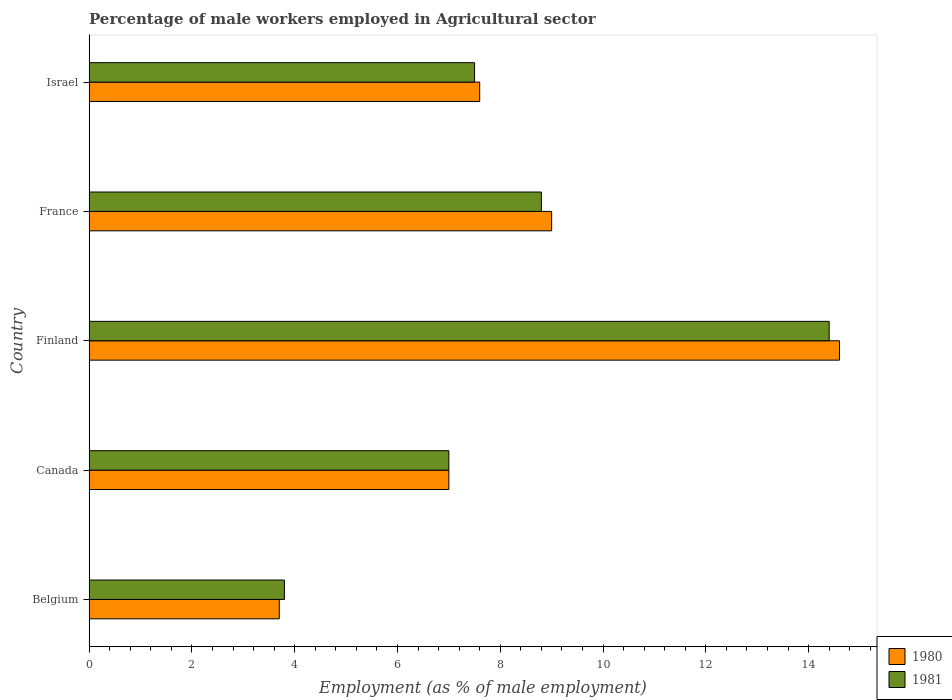How many groups of bars are there?
Provide a short and direct response. 5. Are the number of bars per tick equal to the number of legend labels?
Ensure brevity in your answer.  Yes. Are the number of bars on each tick of the Y-axis equal?
Keep it short and to the point. Yes. How many bars are there on the 5th tick from the top?
Provide a short and direct response. 2. What is the label of the 1st group of bars from the top?
Your response must be concise. Israel. What is the percentage of male workers employed in Agricultural sector in 1980 in Belgium?
Make the answer very short. 3.7. Across all countries, what is the maximum percentage of male workers employed in Agricultural sector in 1980?
Give a very brief answer. 14.6. Across all countries, what is the minimum percentage of male workers employed in Agricultural sector in 1981?
Ensure brevity in your answer.  3.8. What is the total percentage of male workers employed in Agricultural sector in 1981 in the graph?
Provide a short and direct response. 41.5. What is the difference between the percentage of male workers employed in Agricultural sector in 1980 in Belgium and that in Israel?
Give a very brief answer. -3.9. What is the average percentage of male workers employed in Agricultural sector in 1981 per country?
Give a very brief answer. 8.3. What is the ratio of the percentage of male workers employed in Agricultural sector in 1980 in Finland to that in Israel?
Your answer should be compact. 1.92. Is the percentage of male workers employed in Agricultural sector in 1980 in Belgium less than that in Finland?
Make the answer very short. Yes. Is the difference between the percentage of male workers employed in Agricultural sector in 1981 in Canada and France greater than the difference between the percentage of male workers employed in Agricultural sector in 1980 in Canada and France?
Provide a succinct answer. Yes. What is the difference between the highest and the second highest percentage of male workers employed in Agricultural sector in 1980?
Offer a very short reply. 5.6. What is the difference between the highest and the lowest percentage of male workers employed in Agricultural sector in 1980?
Provide a succinct answer. 10.9. Is the sum of the percentage of male workers employed in Agricultural sector in 1980 in Belgium and Finland greater than the maximum percentage of male workers employed in Agricultural sector in 1981 across all countries?
Keep it short and to the point. Yes. What does the 1st bar from the top in Belgium represents?
Provide a succinct answer. 1981. What does the 2nd bar from the bottom in Belgium represents?
Offer a very short reply. 1981. How many bars are there?
Your response must be concise. 10. How many countries are there in the graph?
Your answer should be compact. 5. What is the difference between two consecutive major ticks on the X-axis?
Offer a terse response. 2. Does the graph contain any zero values?
Provide a succinct answer. No. What is the title of the graph?
Provide a short and direct response. Percentage of male workers employed in Agricultural sector. What is the label or title of the X-axis?
Your answer should be very brief. Employment (as % of male employment). What is the label or title of the Y-axis?
Your answer should be compact. Country. What is the Employment (as % of male employment) in 1980 in Belgium?
Your answer should be very brief. 3.7. What is the Employment (as % of male employment) in 1981 in Belgium?
Your answer should be very brief. 3.8. What is the Employment (as % of male employment) in 1980 in Canada?
Give a very brief answer. 7. What is the Employment (as % of male employment) in 1981 in Canada?
Your response must be concise. 7. What is the Employment (as % of male employment) of 1980 in Finland?
Provide a short and direct response. 14.6. What is the Employment (as % of male employment) of 1981 in Finland?
Ensure brevity in your answer.  14.4. What is the Employment (as % of male employment) in 1980 in France?
Your answer should be compact. 9. What is the Employment (as % of male employment) in 1981 in France?
Offer a very short reply. 8.8. What is the Employment (as % of male employment) in 1980 in Israel?
Your response must be concise. 7.6. Across all countries, what is the maximum Employment (as % of male employment) of 1980?
Give a very brief answer. 14.6. Across all countries, what is the maximum Employment (as % of male employment) in 1981?
Ensure brevity in your answer.  14.4. Across all countries, what is the minimum Employment (as % of male employment) of 1980?
Your answer should be very brief. 3.7. Across all countries, what is the minimum Employment (as % of male employment) in 1981?
Your answer should be compact. 3.8. What is the total Employment (as % of male employment) in 1980 in the graph?
Offer a terse response. 41.9. What is the total Employment (as % of male employment) of 1981 in the graph?
Offer a terse response. 41.5. What is the difference between the Employment (as % of male employment) of 1980 in Belgium and that in Canada?
Your answer should be very brief. -3.3. What is the difference between the Employment (as % of male employment) in 1981 in Belgium and that in Canada?
Your answer should be compact. -3.2. What is the difference between the Employment (as % of male employment) in 1980 in Belgium and that in Finland?
Your answer should be very brief. -10.9. What is the difference between the Employment (as % of male employment) of 1981 in Belgium and that in France?
Provide a succinct answer. -5. What is the difference between the Employment (as % of male employment) of 1981 in Canada and that in Finland?
Provide a short and direct response. -7.4. What is the difference between the Employment (as % of male employment) of 1980 in Canada and that in France?
Keep it short and to the point. -2. What is the difference between the Employment (as % of male employment) of 1980 in Canada and that in Israel?
Your response must be concise. -0.6. What is the difference between the Employment (as % of male employment) of 1981 in Finland and that in Israel?
Provide a succinct answer. 6.9. What is the difference between the Employment (as % of male employment) in 1980 in France and that in Israel?
Make the answer very short. 1.4. What is the difference between the Employment (as % of male employment) in 1981 in France and that in Israel?
Offer a terse response. 1.3. What is the difference between the Employment (as % of male employment) of 1980 in Belgium and the Employment (as % of male employment) of 1981 in Israel?
Your answer should be compact. -3.8. What is the difference between the Employment (as % of male employment) in 1980 in Canada and the Employment (as % of male employment) in 1981 in Finland?
Provide a succinct answer. -7.4. What is the difference between the Employment (as % of male employment) of 1980 in Canada and the Employment (as % of male employment) of 1981 in Israel?
Offer a terse response. -0.5. What is the difference between the Employment (as % of male employment) of 1980 in France and the Employment (as % of male employment) of 1981 in Israel?
Give a very brief answer. 1.5. What is the average Employment (as % of male employment) in 1980 per country?
Provide a short and direct response. 8.38. What is the average Employment (as % of male employment) of 1981 per country?
Give a very brief answer. 8.3. What is the difference between the Employment (as % of male employment) in 1980 and Employment (as % of male employment) in 1981 in France?
Ensure brevity in your answer.  0.2. What is the difference between the Employment (as % of male employment) in 1980 and Employment (as % of male employment) in 1981 in Israel?
Give a very brief answer. 0.1. What is the ratio of the Employment (as % of male employment) of 1980 in Belgium to that in Canada?
Provide a short and direct response. 0.53. What is the ratio of the Employment (as % of male employment) of 1981 in Belgium to that in Canada?
Offer a terse response. 0.54. What is the ratio of the Employment (as % of male employment) in 1980 in Belgium to that in Finland?
Offer a terse response. 0.25. What is the ratio of the Employment (as % of male employment) in 1981 in Belgium to that in Finland?
Provide a succinct answer. 0.26. What is the ratio of the Employment (as % of male employment) in 1980 in Belgium to that in France?
Give a very brief answer. 0.41. What is the ratio of the Employment (as % of male employment) in 1981 in Belgium to that in France?
Provide a succinct answer. 0.43. What is the ratio of the Employment (as % of male employment) in 1980 in Belgium to that in Israel?
Your answer should be compact. 0.49. What is the ratio of the Employment (as % of male employment) of 1981 in Belgium to that in Israel?
Give a very brief answer. 0.51. What is the ratio of the Employment (as % of male employment) in 1980 in Canada to that in Finland?
Provide a succinct answer. 0.48. What is the ratio of the Employment (as % of male employment) in 1981 in Canada to that in Finland?
Keep it short and to the point. 0.49. What is the ratio of the Employment (as % of male employment) of 1981 in Canada to that in France?
Your response must be concise. 0.8. What is the ratio of the Employment (as % of male employment) of 1980 in Canada to that in Israel?
Your answer should be compact. 0.92. What is the ratio of the Employment (as % of male employment) of 1981 in Canada to that in Israel?
Your answer should be very brief. 0.93. What is the ratio of the Employment (as % of male employment) in 1980 in Finland to that in France?
Your answer should be compact. 1.62. What is the ratio of the Employment (as % of male employment) in 1981 in Finland to that in France?
Keep it short and to the point. 1.64. What is the ratio of the Employment (as % of male employment) of 1980 in Finland to that in Israel?
Your answer should be very brief. 1.92. What is the ratio of the Employment (as % of male employment) in 1981 in Finland to that in Israel?
Your response must be concise. 1.92. What is the ratio of the Employment (as % of male employment) of 1980 in France to that in Israel?
Keep it short and to the point. 1.18. What is the ratio of the Employment (as % of male employment) in 1981 in France to that in Israel?
Your response must be concise. 1.17. What is the difference between the highest and the second highest Employment (as % of male employment) of 1981?
Provide a succinct answer. 5.6. 